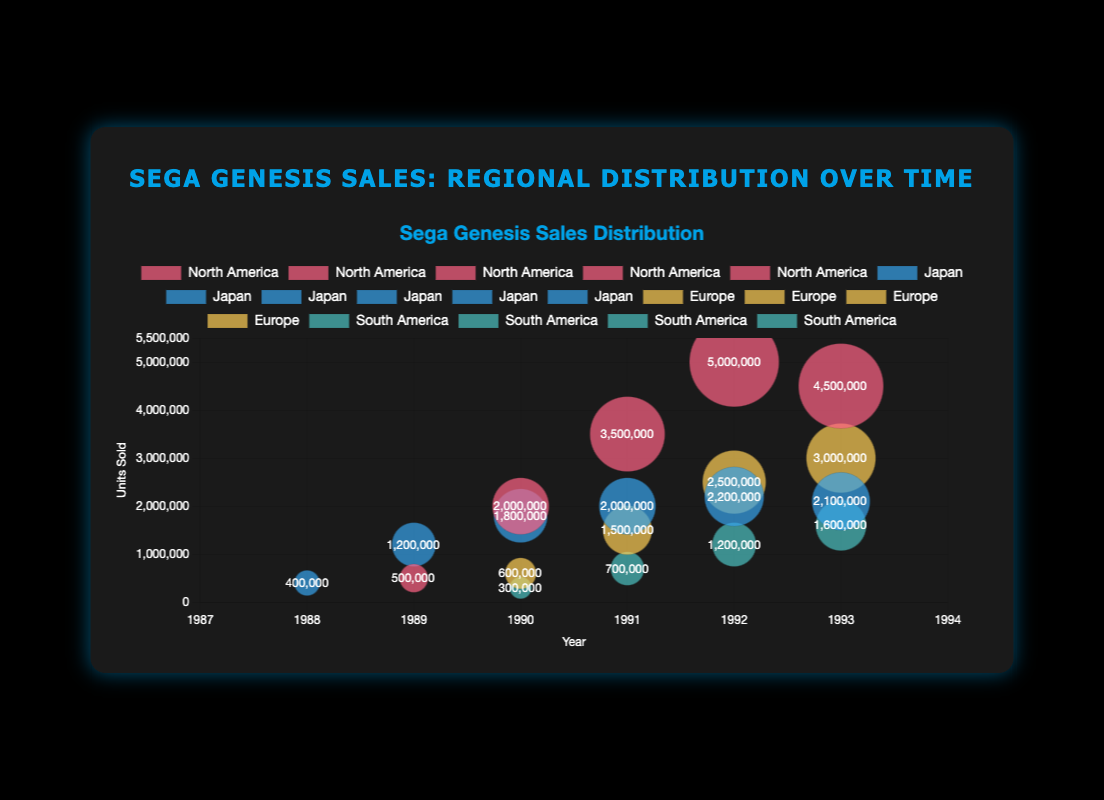How many units were sold in North America in 1991? Look at the bubble corresponding to North America in 1991 and read the y-axis value. The bubble size and data label indicate 3,500,000 units sold.
Answer: 3,500,000 Which region had the highest number of units sold in 1992? To find the region with the highest units sold in 1992, compare the y-values of the bubbles for all regions in that year. North America has the highest, with 5,000,000 units sold.
Answer: North America What is the combined number of units sold in Japan across all years shown? Sum the units sold for Japan over the years: 400,000 + 1,200,000 + 1,800,000 + 2,000,000 + 2,200,000 + 2,100,000 = 9,700,000.
Answer: 9,700,000 Was there an increase in units sold in Europe from 1991 to 1992? To determine this, compare the units sold in 1991 (1,500,000) and 1992 (2,500,000) by looking at the y-values of the respective bubbles. There is an increase of 1,000,000 units.
Answer: Yes Which year saw the highest units sold in South America? Check the bubbles for South America and find the maximum y-value, which is in 1993 with 1,600,000 units sold.
Answer: 1993 How many more units were sold in North America in 1992 compared to Japan in 1992? Subtract the units sold in Japan from those in North America for 1992: 5,000,000 - 2,200,000 = 2,800,000 units.
Answer: 2,800,000 What's the average number of units sold annually in Europe from 1990 to 1993? Average = (600,000 + 1,500,000 + 2,500,000 + 3,000,000) / 4 = 1,900,000 units.
Answer: 1,900,000 Did units sold in North America ever decrease from one year to the next? Compare the North America bubbles' y-values across the years. There is a decrease from 1992 (5,000,000) to 1993 (4,500,000).
Answer: Yes 